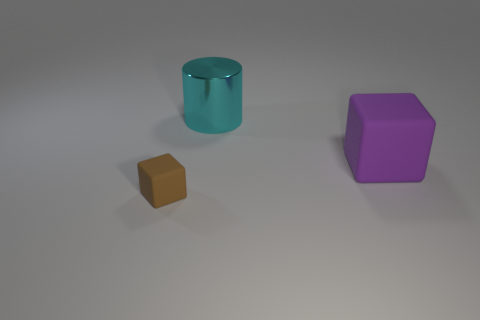Add 2 big metallic things. How many objects exist? 5 Subtract all cylinders. How many objects are left? 2 Add 2 small objects. How many small objects are left? 3 Add 3 small red spheres. How many small red spheres exist? 3 Subtract 0 blue balls. How many objects are left? 3 Subtract all large brown matte balls. Subtract all brown blocks. How many objects are left? 2 